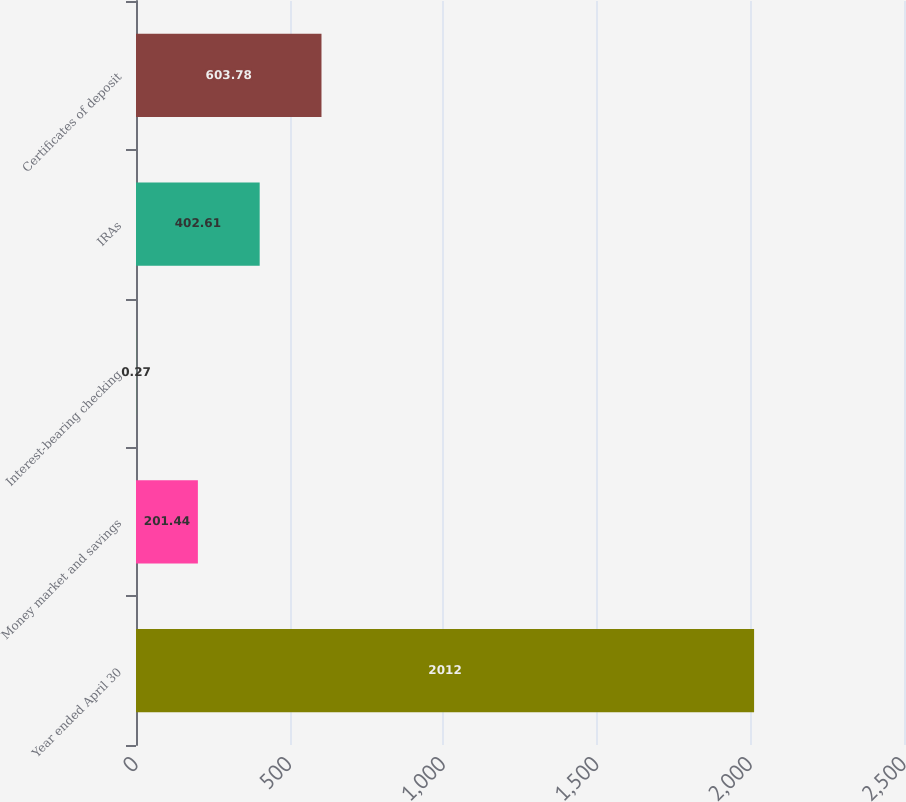<chart> <loc_0><loc_0><loc_500><loc_500><bar_chart><fcel>Year ended April 30<fcel>Money market and savings<fcel>Interest-bearing checking<fcel>IRAs<fcel>Certificates of deposit<nl><fcel>2012<fcel>201.44<fcel>0.27<fcel>402.61<fcel>603.78<nl></chart> 